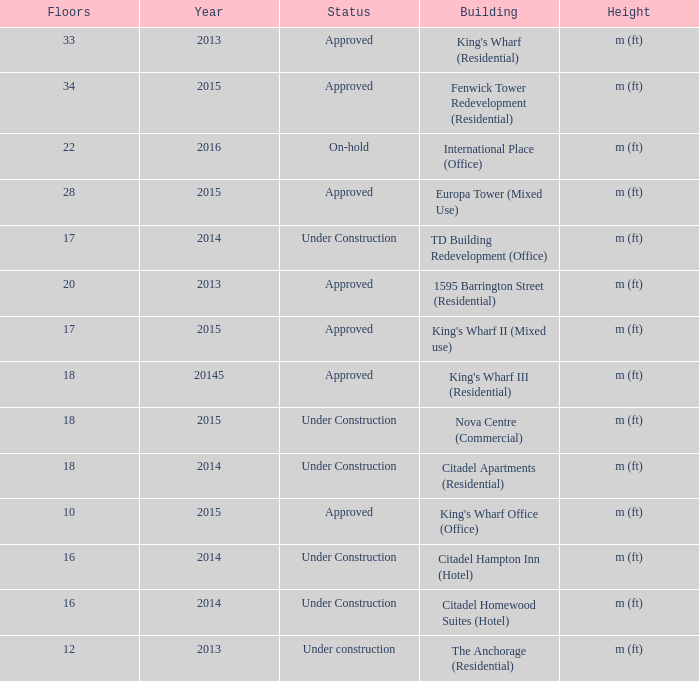What is the status of the building with less than 18 floors and later than 2013? Under Construction, Approved, Approved, Under Construction, Under Construction. 